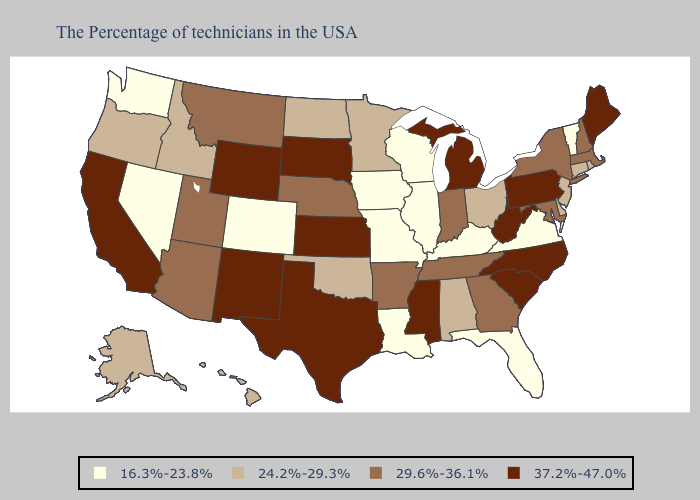Does Oklahoma have the highest value in the USA?
Be succinct. No. Which states have the lowest value in the West?
Answer briefly. Colorado, Nevada, Washington. Among the states that border Missouri , which have the lowest value?
Keep it brief. Kentucky, Illinois, Iowa. What is the lowest value in the MidWest?
Concise answer only. 16.3%-23.8%. What is the highest value in the USA?
Answer briefly. 37.2%-47.0%. Does the map have missing data?
Keep it brief. No. What is the value of New Mexico?
Be succinct. 37.2%-47.0%. Among the states that border Colorado , which have the lowest value?
Give a very brief answer. Oklahoma. Which states have the lowest value in the West?
Give a very brief answer. Colorado, Nevada, Washington. Does South Carolina have a higher value than New Mexico?
Write a very short answer. No. Does Colorado have the lowest value in the West?
Write a very short answer. Yes. Which states have the lowest value in the USA?
Short answer required. Vermont, Virginia, Florida, Kentucky, Wisconsin, Illinois, Louisiana, Missouri, Iowa, Colorado, Nevada, Washington. What is the value of Minnesota?
Concise answer only. 24.2%-29.3%. Which states hav the highest value in the South?
Give a very brief answer. North Carolina, South Carolina, West Virginia, Mississippi, Texas. 